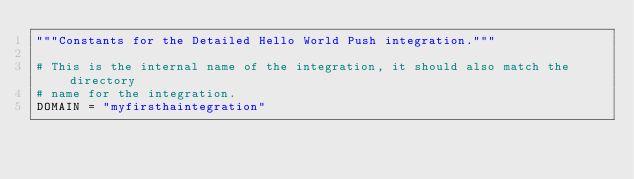Convert code to text. <code><loc_0><loc_0><loc_500><loc_500><_Python_>"""Constants for the Detailed Hello World Push integration."""

# This is the internal name of the integration, it should also match the directory
# name for the integration.
DOMAIN = "myfirsthaintegration"
</code> 